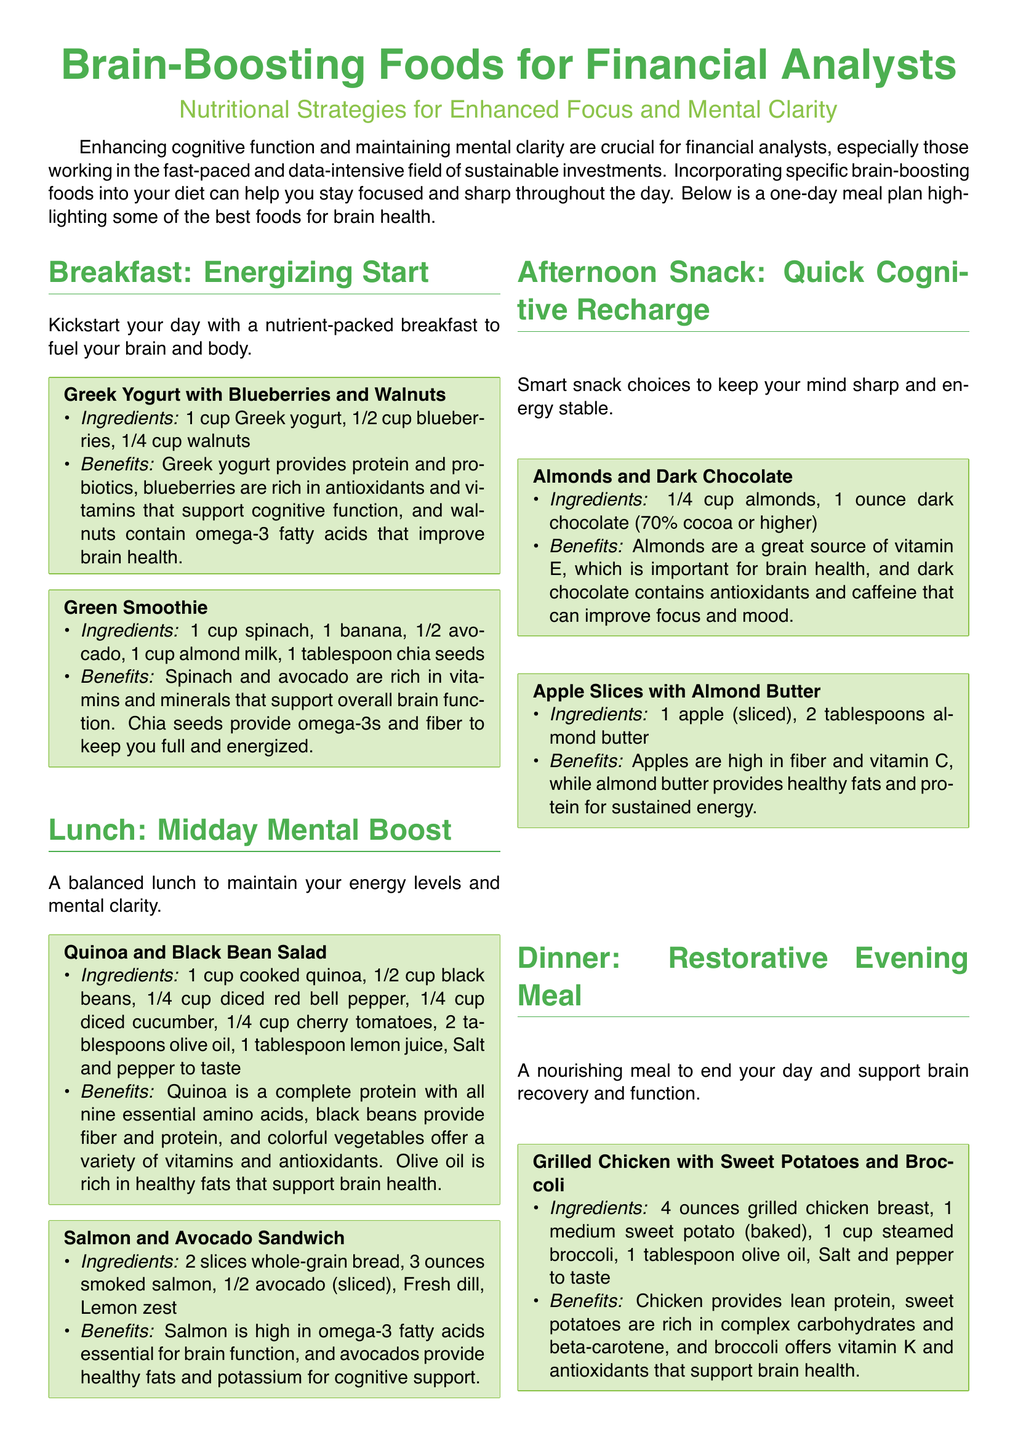What is the first meal of the day in the plan? The first meal presented in the document is breakfast, specifically the Greek Yogurt with Blueberries and Walnuts.
Answer: Greek Yogurt with Blueberries and Walnuts How many ingredients are listed for the Green Smoothie? The Green Smoothie recipe contains five listed ingredients: spinach, banana, avocado, almond milk, and chia seeds.
Answer: 5 What type of nuts are included in the afternoon snack options? The afternoon snack options listed include almonds and dark chocolate, which contain almonds as the nut.
Answer: Almonds What benefits do walnuts provide according to the breakfast meal? Walnuts are noted for containing omega-3 fatty acids that improve brain health.
Answer: Omega-3 fatty acids How many ounces of smoked salmon are used in the sandwich? The sandwich recipe requires three ounces of smoked salmon.
Answer: 3 ounces What nutrient is primarily provided by Greek yogurt? Greek yogurt provides protein as one of its main nutrients.
Answer: Protein Which meal includes sweet potatoes? The Grilled Chicken with Sweet Potatoes and Broccoli meal includes sweet potatoes.
Answer: Grilled Chicken with Sweet Potatoes and Broccoli How many cups of vegetable broth are used in the Lentil Soup? The Lentil Soup recipe specifies the use of four cups of vegetable broth.
Answer: 4 cups What is the main type of protein in the dinner meal? The dinner meal focuses on grilled chicken as the main type of protein.
Answer: Grilled chicken What is the recommended cocoa percentage for dark chocolate in the snacks? The document recommends dark chocolate with a minimum cocoa percentage of 70%.
Answer: 70% 